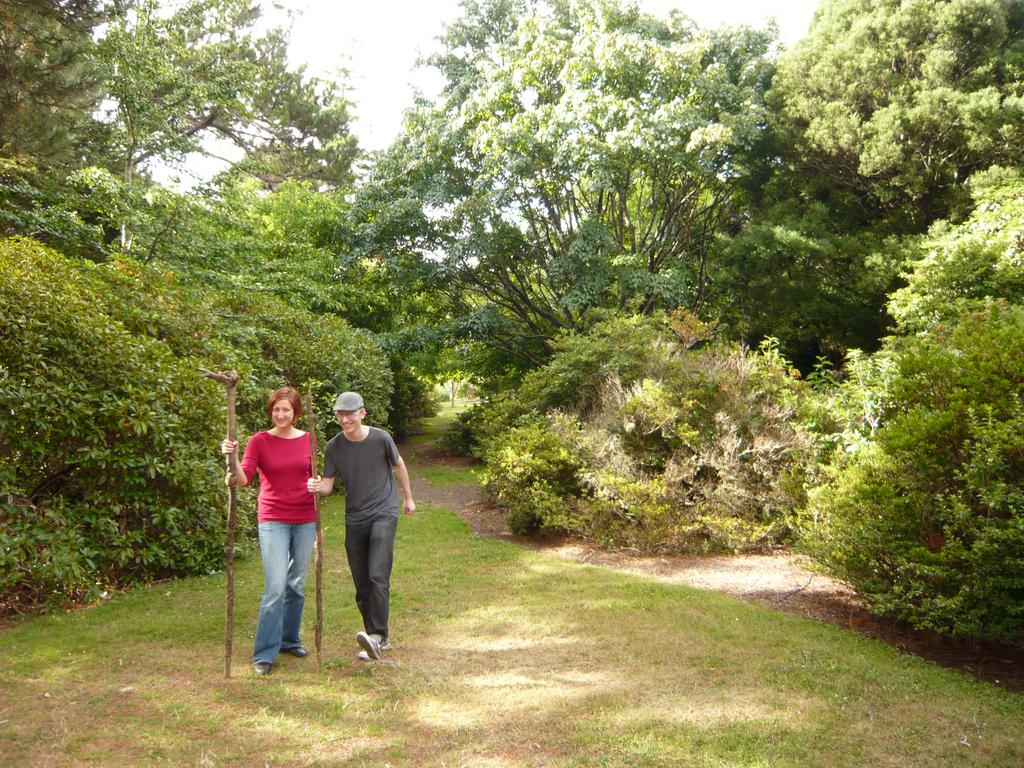How many people are present in the image? There are two people in the image. What are the people holding in their hands? The people are holding sticks in the image. What can be seen in the background of the image? There are trees, grass, and the sky visible in the background of the image. How many cows are visible in the image? There are no cows present in the image. What type of nest can be seen in the trees in the background? There is no nest visible in the trees in the background of the image. 